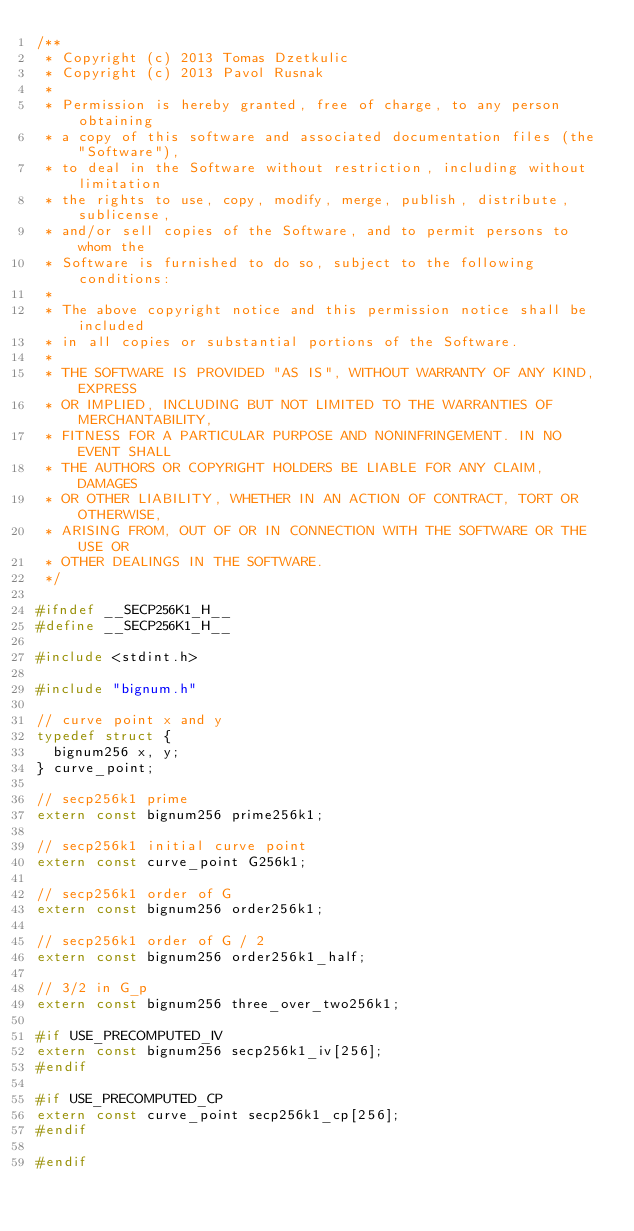<code> <loc_0><loc_0><loc_500><loc_500><_C_>/**
 * Copyright (c) 2013 Tomas Dzetkulic
 * Copyright (c) 2013 Pavol Rusnak
 *
 * Permission is hereby granted, free of charge, to any person obtaining
 * a copy of this software and associated documentation files (the "Software"),
 * to deal in the Software without restriction, including without limitation
 * the rights to use, copy, modify, merge, publish, distribute, sublicense,
 * and/or sell copies of the Software, and to permit persons to whom the
 * Software is furnished to do so, subject to the following conditions:
 *
 * The above copyright notice and this permission notice shall be included
 * in all copies or substantial portions of the Software.
 *
 * THE SOFTWARE IS PROVIDED "AS IS", WITHOUT WARRANTY OF ANY KIND, EXPRESS
 * OR IMPLIED, INCLUDING BUT NOT LIMITED TO THE WARRANTIES OF MERCHANTABILITY,
 * FITNESS FOR A PARTICULAR PURPOSE AND NONINFRINGEMENT. IN NO EVENT SHALL
 * THE AUTHORS OR COPYRIGHT HOLDERS BE LIABLE FOR ANY CLAIM, DAMAGES
 * OR OTHER LIABILITY, WHETHER IN AN ACTION OF CONTRACT, TORT OR OTHERWISE,
 * ARISING FROM, OUT OF OR IN CONNECTION WITH THE SOFTWARE OR THE USE OR
 * OTHER DEALINGS IN THE SOFTWARE.
 */

#ifndef __SECP256K1_H__
#define __SECP256K1_H__

#include <stdint.h>

#include "bignum.h"

// curve point x and y
typedef struct {
	bignum256 x, y;
} curve_point;

// secp256k1 prime
extern const bignum256 prime256k1;

// secp256k1 initial curve point
extern const curve_point G256k1;

// secp256k1 order of G
extern const bignum256 order256k1;

// secp256k1 order of G / 2
extern const bignum256 order256k1_half;

// 3/2 in G_p
extern const bignum256 three_over_two256k1;

#if USE_PRECOMPUTED_IV
extern const bignum256 secp256k1_iv[256];
#endif

#if USE_PRECOMPUTED_CP
extern const curve_point secp256k1_cp[256];
#endif

#endif
</code> 